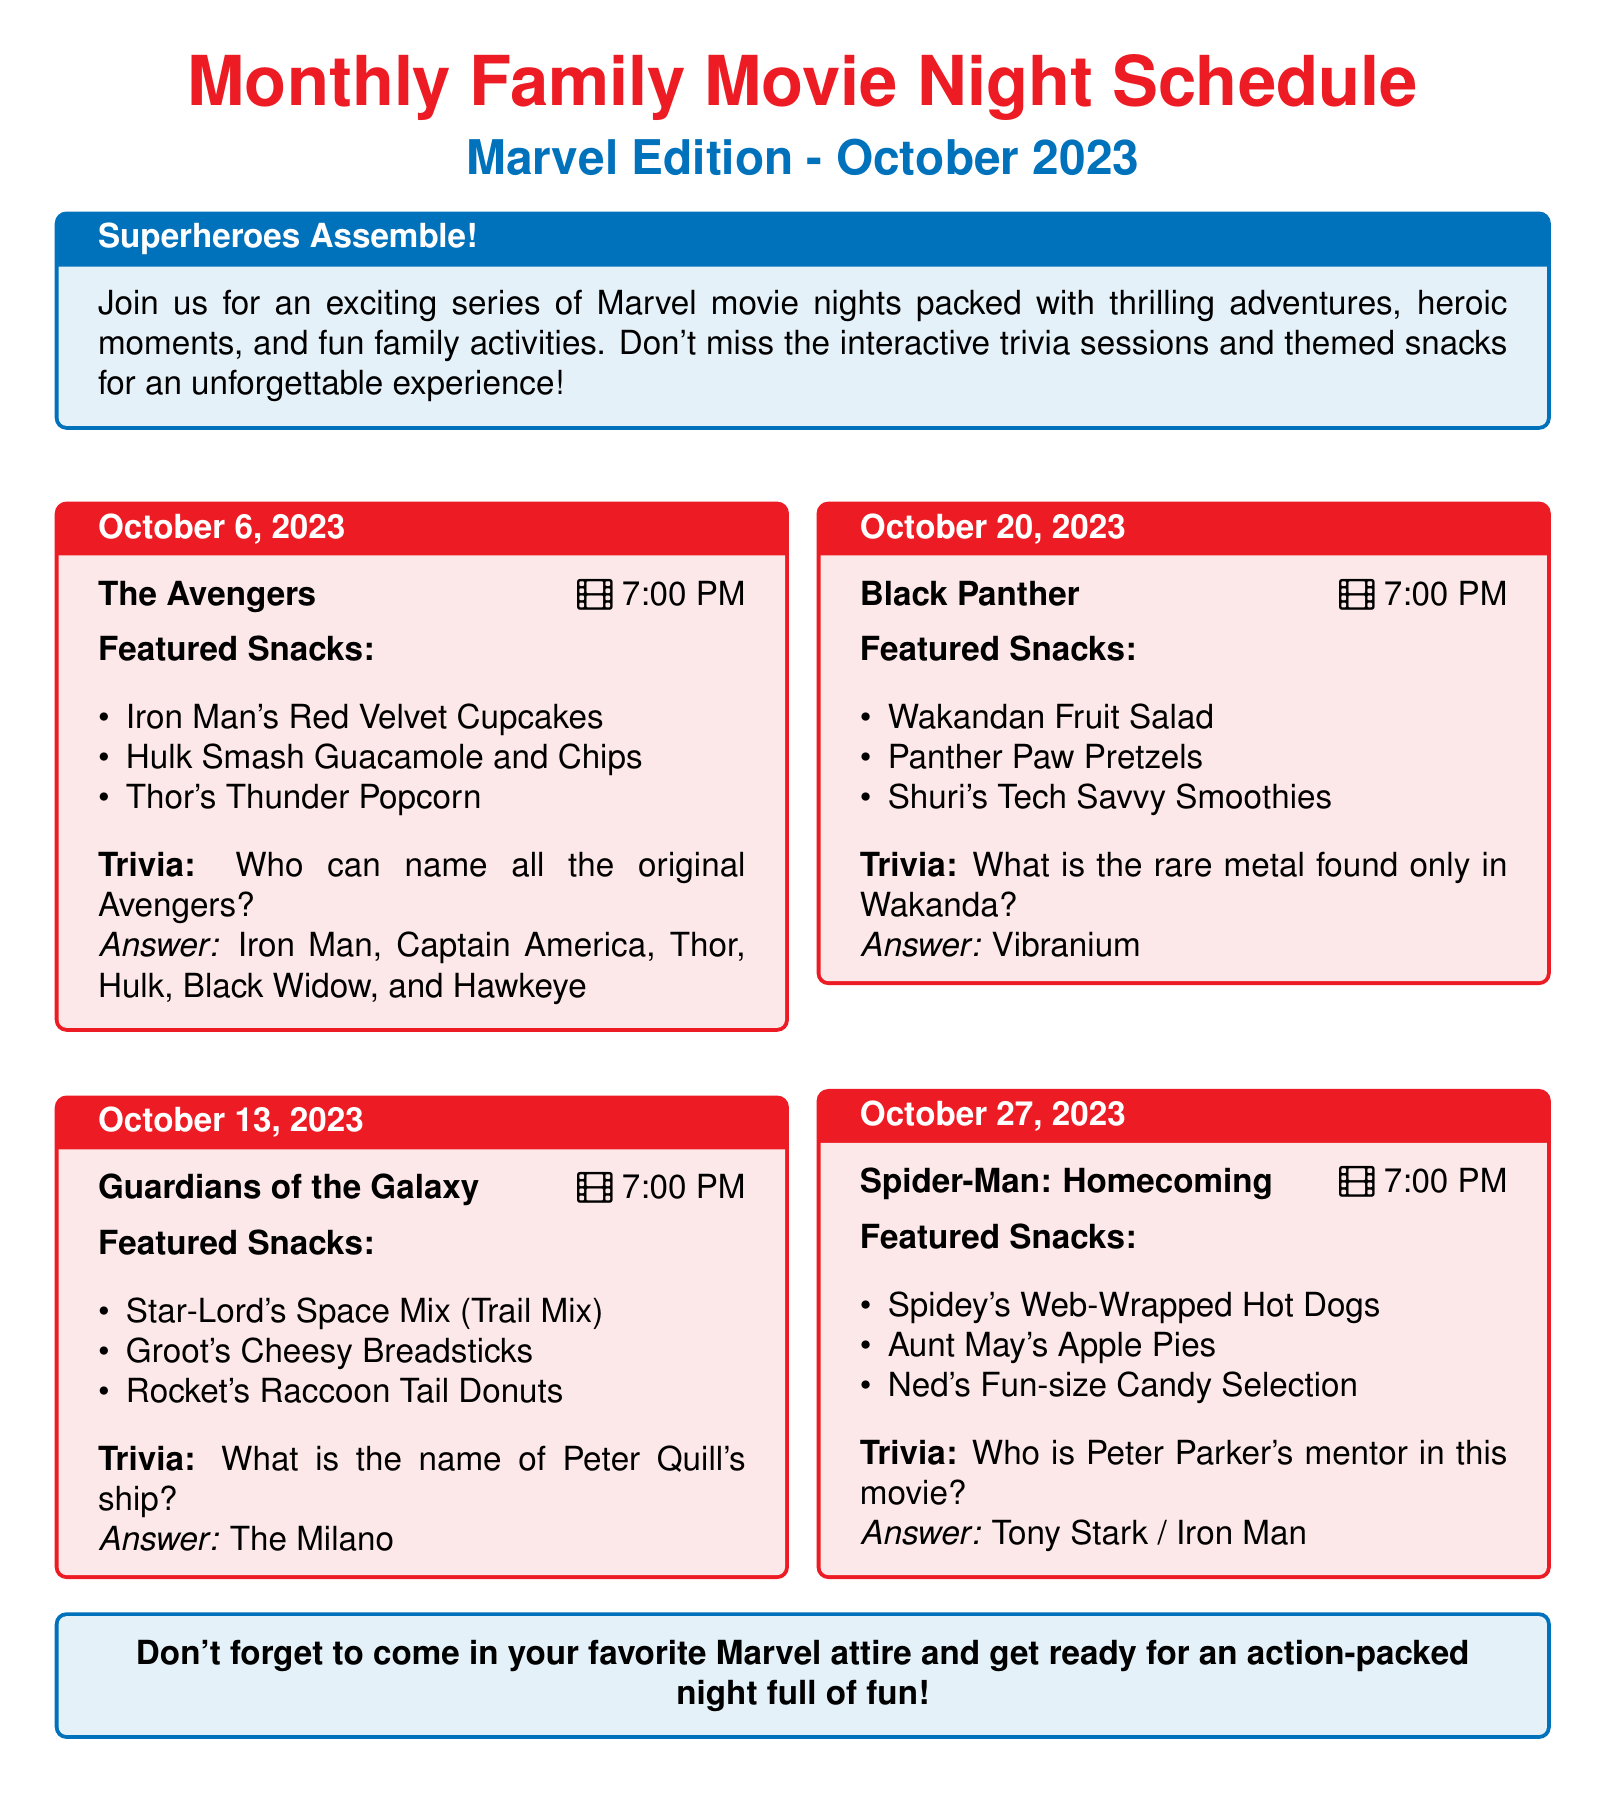What is the date of the first movie night? The date of the first movie night is mentioned in the schedule, which is October 6, 2023.
Answer: October 6, 2023 What time does the Black Panther movie start? The schedule specifies that Black Panther starts at 7:00 PM.
Answer: 7:00 PM What is one of the featured snacks for Guardians of the Galaxy? The document lists various snacks, including Star-Lord's Space Mix (Trail Mix).
Answer: Star-Lord's Space Mix How many Marvel movie nights are scheduled for October 2023? The document lists movies on four different dates in October 2023.
Answer: Four What is the trivia question for Spider-Man: Homecoming? The trivia question listed for Spider-Man: Homecoming asks who Peter Parker's mentor is.
Answer: Who is Peter Parker's mentor in this movie? What is the featured snack for The Avengers movie night? The standout snacks for The Avengers night include Iron Man's Red Velvet Cupcakes.
Answer: Iron Man's Red Velvet Cupcakes What interactive activity is included with the movie nights? The document notes the inclusion of interactive trivia sessions during the movie nights.
Answer: Trivia sessions What is the answer to the trivia for Black Panther? The answer to the trivia question regarding Black Panther focuses on the rare metal in Wakanda.
Answer: Vibranium 